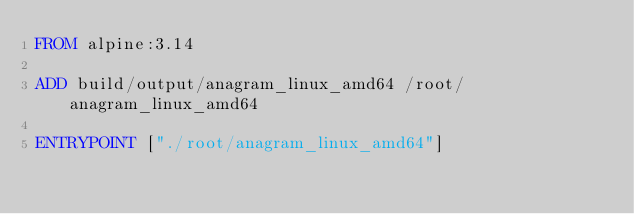<code> <loc_0><loc_0><loc_500><loc_500><_Dockerfile_>FROM alpine:3.14

ADD build/output/anagram_linux_amd64 /root/anagram_linux_amd64

ENTRYPOINT ["./root/anagram_linux_amd64"]
</code> 